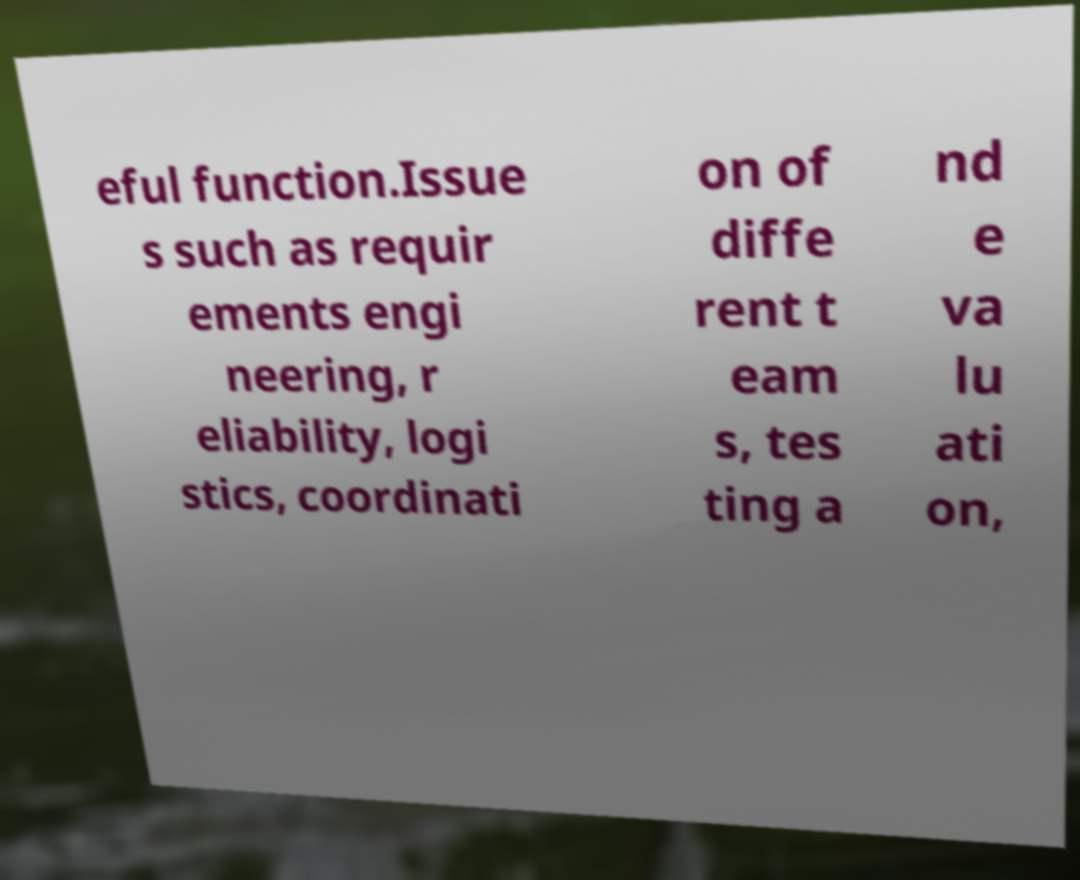For documentation purposes, I need the text within this image transcribed. Could you provide that? eful function.Issue s such as requir ements engi neering, r eliability, logi stics, coordinati on of diffe rent t eam s, tes ting a nd e va lu ati on, 